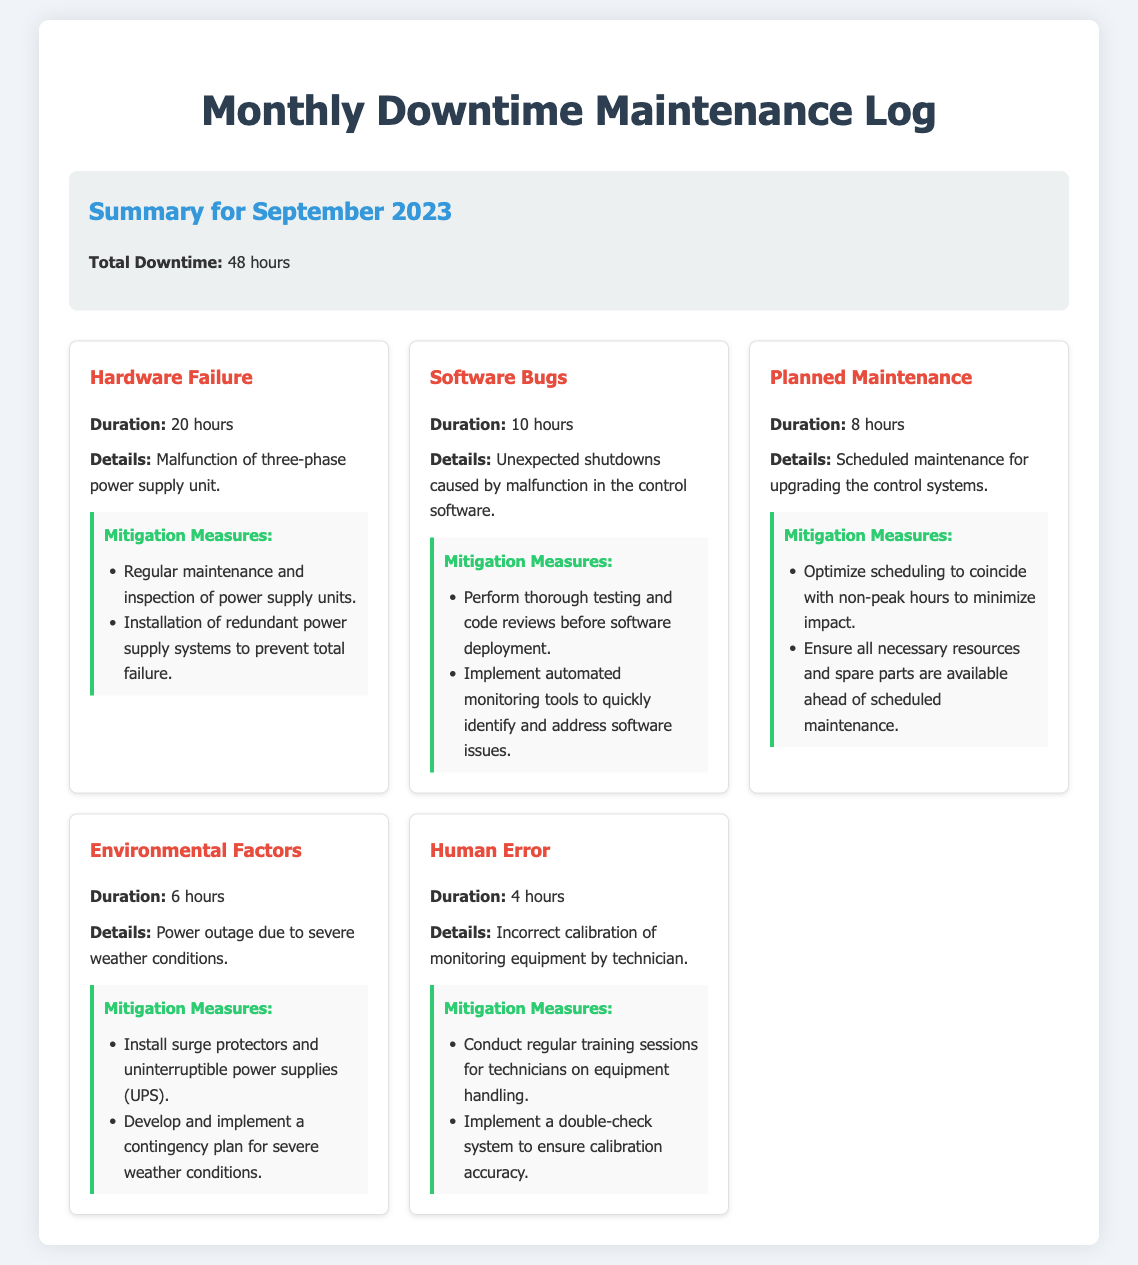What is the total downtime for September 2023? The total downtime is explicitly mentioned in the summary section of the document.
Answer: 48 hours How many hours of downtime were caused by hardware failure? The duration for hardware failure is specified under the reasons section.
Answer: 20 hours What was the reason for 10 hours of downtime? This information can be found in the reasons section where each downtime category is listed with a corresponding duration.
Answer: Software Bugs How many hours were assigned to planned maintenance? The planned maintenance duration is included in the reasons section of the document.
Answer: 8 hours What mitigation measure is suggested for environmental factors? The mitigation measures are detailed under the environmental factors section, providing specific actions to take.
Answer: Install surge protectors and uninterruptible power supplies (UPS) What kind of maintenance caused 4 hours of downtime? The reason for the downtime can be found in the reasons section describing human error.
Answer: Human Error What is the duration attributed to environmental factors? The duration for environmental factors is listed in the corresponding reason section of the document.
Answer: 6 hours What mitigation measure is suggested for software bugs? The document outlines mitigation measures specifically to address issues related to software bugs.
Answer: Perform thorough testing and code reviews before software deployment 